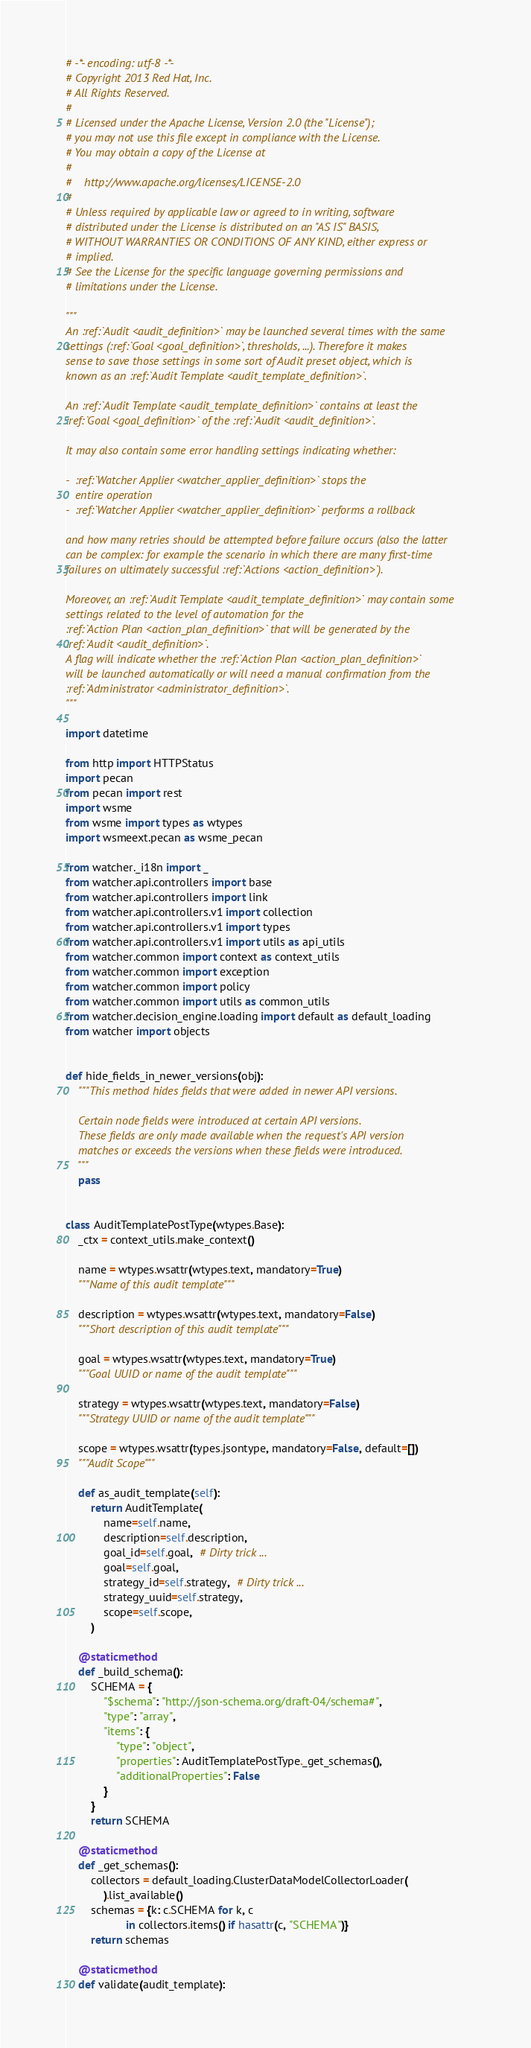<code> <loc_0><loc_0><loc_500><loc_500><_Python_># -*- encoding: utf-8 -*-
# Copyright 2013 Red Hat, Inc.
# All Rights Reserved.
#
# Licensed under the Apache License, Version 2.0 (the "License");
# you may not use this file except in compliance with the License.
# You may obtain a copy of the License at
#
#    http://www.apache.org/licenses/LICENSE-2.0
#
# Unless required by applicable law or agreed to in writing, software
# distributed under the License is distributed on an "AS IS" BASIS,
# WITHOUT WARRANTIES OR CONDITIONS OF ANY KIND, either express or
# implied.
# See the License for the specific language governing permissions and
# limitations under the License.

"""
An :ref:`Audit <audit_definition>` may be launched several times with the same
settings (:ref:`Goal <goal_definition>`, thresholds, ...). Therefore it makes
sense to save those settings in some sort of Audit preset object, which is
known as an :ref:`Audit Template <audit_template_definition>`.

An :ref:`Audit Template <audit_template_definition>` contains at least the
:ref:`Goal <goal_definition>` of the :ref:`Audit <audit_definition>`.

It may also contain some error handling settings indicating whether:

-  :ref:`Watcher Applier <watcher_applier_definition>` stops the
   entire operation
-  :ref:`Watcher Applier <watcher_applier_definition>` performs a rollback

and how many retries should be attempted before failure occurs (also the latter
can be complex: for example the scenario in which there are many first-time
failures on ultimately successful :ref:`Actions <action_definition>`).

Moreover, an :ref:`Audit Template <audit_template_definition>` may contain some
settings related to the level of automation for the
:ref:`Action Plan <action_plan_definition>` that will be generated by the
:ref:`Audit <audit_definition>`.
A flag will indicate whether the :ref:`Action Plan <action_plan_definition>`
will be launched automatically or will need a manual confirmation from the
:ref:`Administrator <administrator_definition>`.
"""

import datetime

from http import HTTPStatus
import pecan
from pecan import rest
import wsme
from wsme import types as wtypes
import wsmeext.pecan as wsme_pecan

from watcher._i18n import _
from watcher.api.controllers import base
from watcher.api.controllers import link
from watcher.api.controllers.v1 import collection
from watcher.api.controllers.v1 import types
from watcher.api.controllers.v1 import utils as api_utils
from watcher.common import context as context_utils
from watcher.common import exception
from watcher.common import policy
from watcher.common import utils as common_utils
from watcher.decision_engine.loading import default as default_loading
from watcher import objects


def hide_fields_in_newer_versions(obj):
    """This method hides fields that were added in newer API versions.

    Certain node fields were introduced at certain API versions.
    These fields are only made available when the request's API version
    matches or exceeds the versions when these fields were introduced.
    """
    pass


class AuditTemplatePostType(wtypes.Base):
    _ctx = context_utils.make_context()

    name = wtypes.wsattr(wtypes.text, mandatory=True)
    """Name of this audit template"""

    description = wtypes.wsattr(wtypes.text, mandatory=False)
    """Short description of this audit template"""

    goal = wtypes.wsattr(wtypes.text, mandatory=True)
    """Goal UUID or name of the audit template"""

    strategy = wtypes.wsattr(wtypes.text, mandatory=False)
    """Strategy UUID or name of the audit template"""

    scope = wtypes.wsattr(types.jsontype, mandatory=False, default=[])
    """Audit Scope"""

    def as_audit_template(self):
        return AuditTemplate(
            name=self.name,
            description=self.description,
            goal_id=self.goal,  # Dirty trick ...
            goal=self.goal,
            strategy_id=self.strategy,  # Dirty trick ...
            strategy_uuid=self.strategy,
            scope=self.scope,
        )

    @staticmethod
    def _build_schema():
        SCHEMA = {
            "$schema": "http://json-schema.org/draft-04/schema#",
            "type": "array",
            "items": {
                "type": "object",
                "properties": AuditTemplatePostType._get_schemas(),
                "additionalProperties": False
            }
        }
        return SCHEMA

    @staticmethod
    def _get_schemas():
        collectors = default_loading.ClusterDataModelCollectorLoader(
            ).list_available()
        schemas = {k: c.SCHEMA for k, c
                   in collectors.items() if hasattr(c, "SCHEMA")}
        return schemas

    @staticmethod
    def validate(audit_template):</code> 